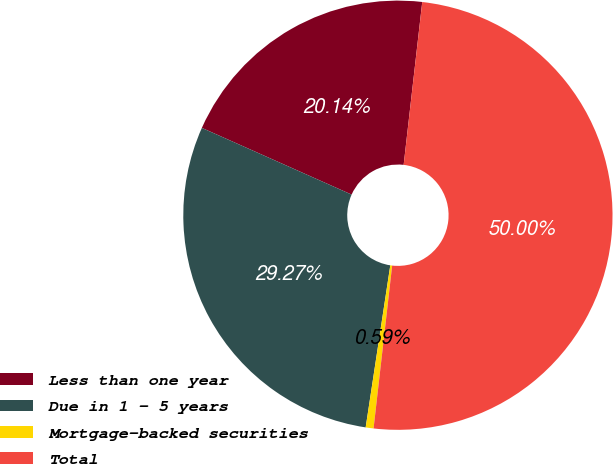<chart> <loc_0><loc_0><loc_500><loc_500><pie_chart><fcel>Less than one year<fcel>Due in 1 - 5 years<fcel>Mortgage-backed securities<fcel>Total<nl><fcel>20.14%<fcel>29.27%<fcel>0.59%<fcel>50.0%<nl></chart> 